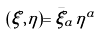Convert formula to latex. <formula><loc_0><loc_0><loc_500><loc_500>( \xi , \eta ) = \bar { \xi } _ { a } \eta ^ { a }</formula> 